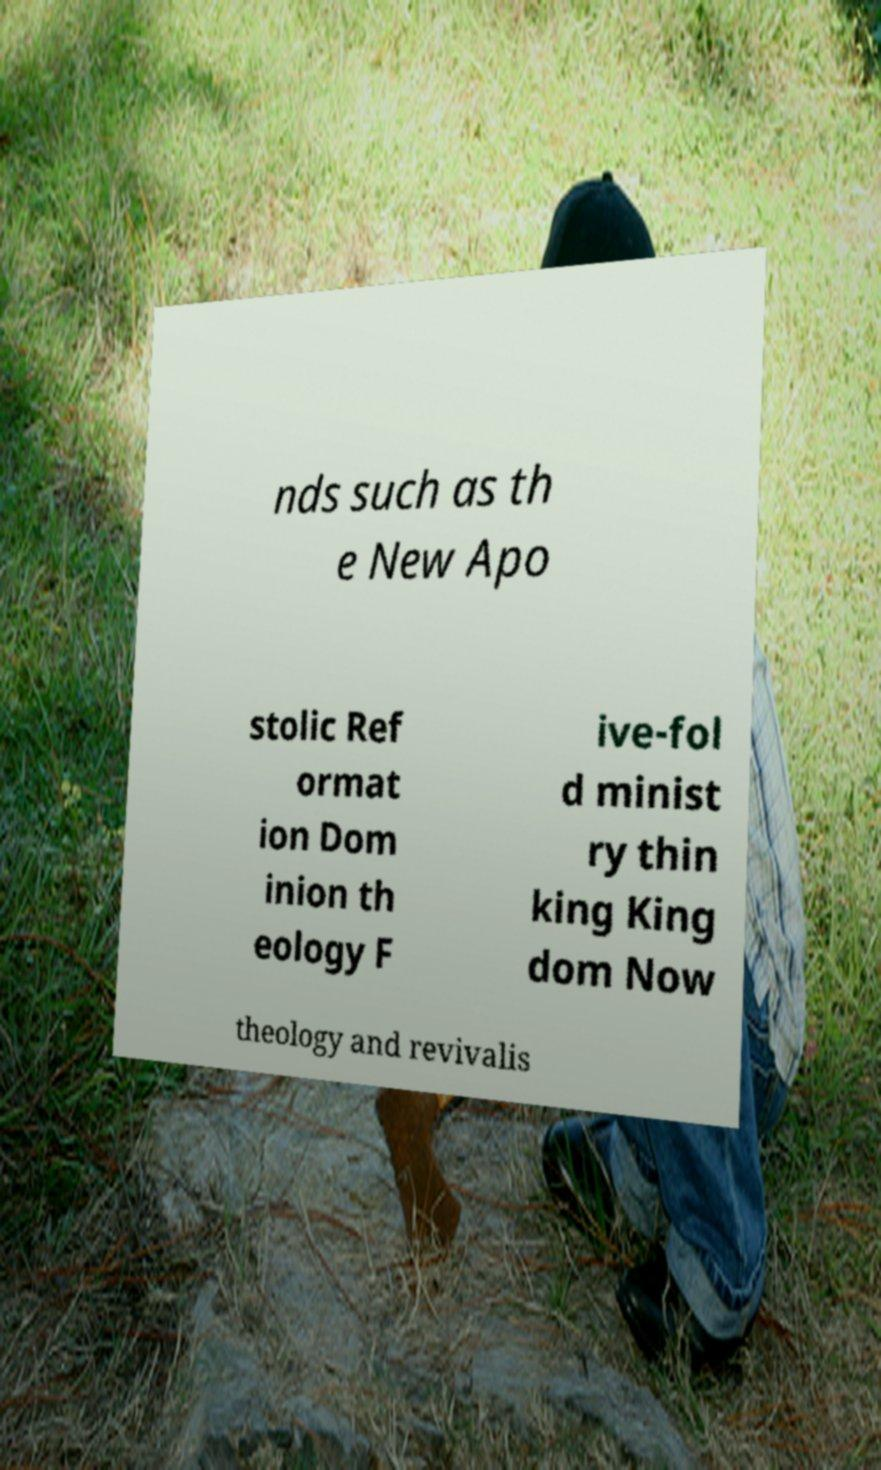There's text embedded in this image that I need extracted. Can you transcribe it verbatim? nds such as th e New Apo stolic Ref ormat ion Dom inion th eology F ive-fol d minist ry thin king King dom Now theology and revivalis 